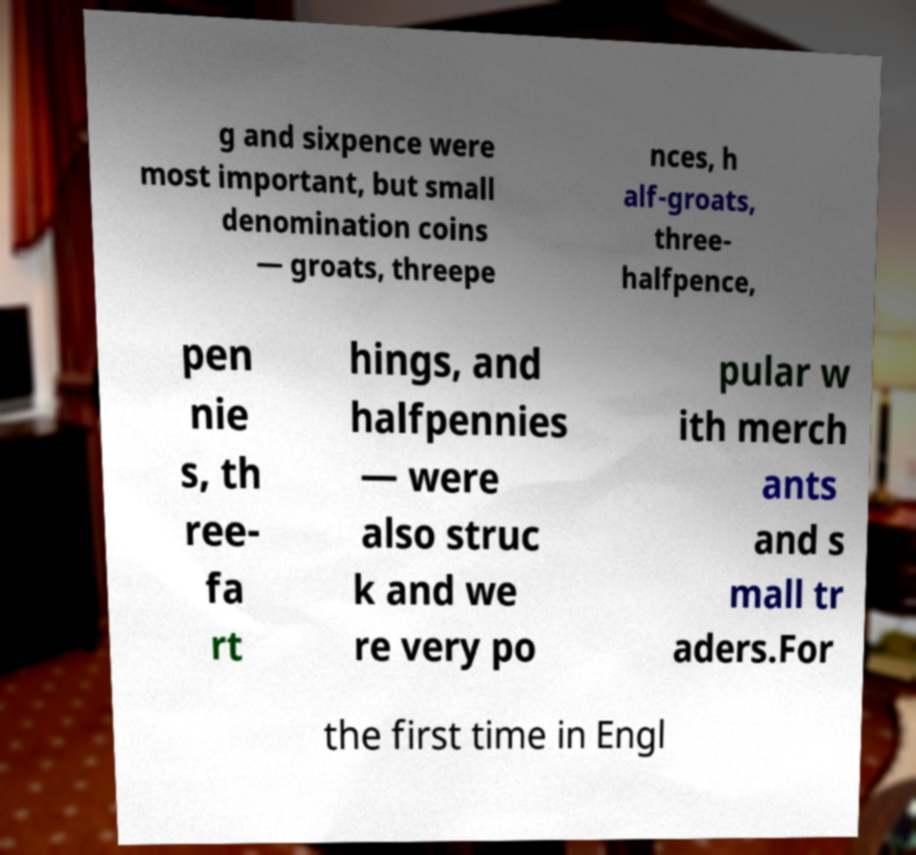Could you assist in decoding the text presented in this image and type it out clearly? g and sixpence were most important, but small denomination coins — groats, threepe nces, h alf-groats, three- halfpence, pen nie s, th ree- fa rt hings, and halfpennies — were also struc k and we re very po pular w ith merch ants and s mall tr aders.For the first time in Engl 